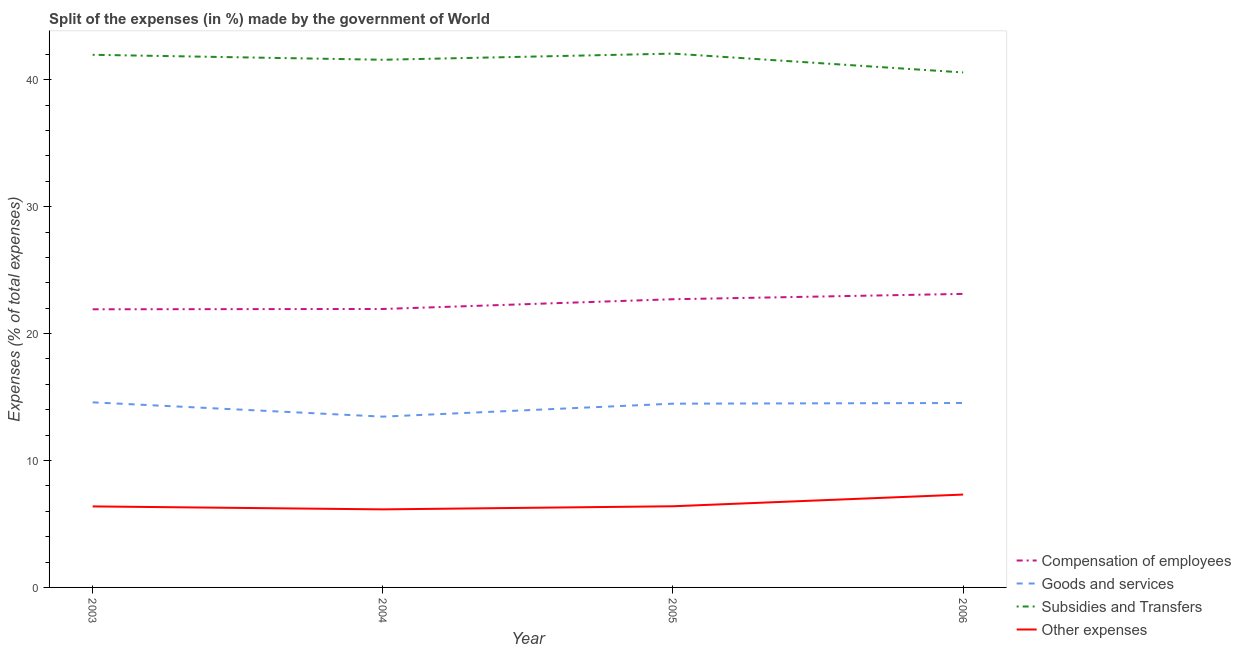Does the line corresponding to percentage of amount spent on subsidies intersect with the line corresponding to percentage of amount spent on compensation of employees?
Offer a very short reply. No. Is the number of lines equal to the number of legend labels?
Ensure brevity in your answer.  Yes. What is the percentage of amount spent on subsidies in 2004?
Provide a succinct answer. 41.58. Across all years, what is the maximum percentage of amount spent on goods and services?
Offer a very short reply. 14.58. Across all years, what is the minimum percentage of amount spent on other expenses?
Provide a succinct answer. 6.15. In which year was the percentage of amount spent on subsidies maximum?
Ensure brevity in your answer.  2005. In which year was the percentage of amount spent on subsidies minimum?
Offer a terse response. 2006. What is the total percentage of amount spent on compensation of employees in the graph?
Your answer should be compact. 89.69. What is the difference between the percentage of amount spent on compensation of employees in 2003 and that in 2005?
Make the answer very short. -0.79. What is the difference between the percentage of amount spent on goods and services in 2006 and the percentage of amount spent on subsidies in 2003?
Your answer should be compact. -27.44. What is the average percentage of amount spent on goods and services per year?
Your response must be concise. 14.26. In the year 2004, what is the difference between the percentage of amount spent on subsidies and percentage of amount spent on compensation of employees?
Provide a short and direct response. 19.64. In how many years, is the percentage of amount spent on compensation of employees greater than 32 %?
Your response must be concise. 0. What is the ratio of the percentage of amount spent on subsidies in 2005 to that in 2006?
Ensure brevity in your answer.  1.04. Is the difference between the percentage of amount spent on subsidies in 2004 and 2006 greater than the difference between the percentage of amount spent on goods and services in 2004 and 2006?
Provide a succinct answer. Yes. What is the difference between the highest and the second highest percentage of amount spent on goods and services?
Keep it short and to the point. 0.05. What is the difference between the highest and the lowest percentage of amount spent on compensation of employees?
Your answer should be very brief. 1.21. In how many years, is the percentage of amount spent on other expenses greater than the average percentage of amount spent on other expenses taken over all years?
Give a very brief answer. 1. Is the sum of the percentage of amount spent on other expenses in 2004 and 2006 greater than the maximum percentage of amount spent on goods and services across all years?
Give a very brief answer. No. Is it the case that in every year, the sum of the percentage of amount spent on goods and services and percentage of amount spent on subsidies is greater than the sum of percentage of amount spent on other expenses and percentage of amount spent on compensation of employees?
Make the answer very short. Yes. Is it the case that in every year, the sum of the percentage of amount spent on compensation of employees and percentage of amount spent on goods and services is greater than the percentage of amount spent on subsidies?
Ensure brevity in your answer.  No. Does the percentage of amount spent on compensation of employees monotonically increase over the years?
Provide a succinct answer. Yes. Is the percentage of amount spent on subsidies strictly less than the percentage of amount spent on compensation of employees over the years?
Offer a terse response. No. How many lines are there?
Your answer should be very brief. 4. What is the difference between two consecutive major ticks on the Y-axis?
Your answer should be very brief. 10. Does the graph contain grids?
Make the answer very short. No. What is the title of the graph?
Give a very brief answer. Split of the expenses (in %) made by the government of World. What is the label or title of the X-axis?
Your answer should be very brief. Year. What is the label or title of the Y-axis?
Keep it short and to the point. Expenses (% of total expenses). What is the Expenses (% of total expenses) in Compensation of employees in 2003?
Ensure brevity in your answer.  21.92. What is the Expenses (% of total expenses) in Goods and services in 2003?
Your response must be concise. 14.58. What is the Expenses (% of total expenses) in Subsidies and Transfers in 2003?
Give a very brief answer. 41.97. What is the Expenses (% of total expenses) of Other expenses in 2003?
Your response must be concise. 6.38. What is the Expenses (% of total expenses) in Compensation of employees in 2004?
Keep it short and to the point. 21.94. What is the Expenses (% of total expenses) in Goods and services in 2004?
Make the answer very short. 13.46. What is the Expenses (% of total expenses) of Subsidies and Transfers in 2004?
Ensure brevity in your answer.  41.58. What is the Expenses (% of total expenses) in Other expenses in 2004?
Make the answer very short. 6.15. What is the Expenses (% of total expenses) in Compensation of employees in 2005?
Ensure brevity in your answer.  22.71. What is the Expenses (% of total expenses) in Goods and services in 2005?
Your answer should be very brief. 14.48. What is the Expenses (% of total expenses) in Subsidies and Transfers in 2005?
Your answer should be compact. 42.06. What is the Expenses (% of total expenses) of Other expenses in 2005?
Your answer should be very brief. 6.39. What is the Expenses (% of total expenses) of Compensation of employees in 2006?
Offer a very short reply. 23.13. What is the Expenses (% of total expenses) in Goods and services in 2006?
Provide a short and direct response. 14.53. What is the Expenses (% of total expenses) of Subsidies and Transfers in 2006?
Offer a terse response. 40.58. What is the Expenses (% of total expenses) of Other expenses in 2006?
Your response must be concise. 7.32. Across all years, what is the maximum Expenses (% of total expenses) in Compensation of employees?
Offer a very short reply. 23.13. Across all years, what is the maximum Expenses (% of total expenses) in Goods and services?
Offer a terse response. 14.58. Across all years, what is the maximum Expenses (% of total expenses) in Subsidies and Transfers?
Make the answer very short. 42.06. Across all years, what is the maximum Expenses (% of total expenses) in Other expenses?
Offer a very short reply. 7.32. Across all years, what is the minimum Expenses (% of total expenses) in Compensation of employees?
Make the answer very short. 21.92. Across all years, what is the minimum Expenses (% of total expenses) in Goods and services?
Ensure brevity in your answer.  13.46. Across all years, what is the minimum Expenses (% of total expenses) of Subsidies and Transfers?
Provide a short and direct response. 40.58. Across all years, what is the minimum Expenses (% of total expenses) of Other expenses?
Offer a very short reply. 6.15. What is the total Expenses (% of total expenses) of Compensation of employees in the graph?
Provide a succinct answer. 89.69. What is the total Expenses (% of total expenses) in Goods and services in the graph?
Your response must be concise. 57.05. What is the total Expenses (% of total expenses) in Subsidies and Transfers in the graph?
Offer a terse response. 166.18. What is the total Expenses (% of total expenses) in Other expenses in the graph?
Make the answer very short. 26.25. What is the difference between the Expenses (% of total expenses) in Compensation of employees in 2003 and that in 2004?
Keep it short and to the point. -0.02. What is the difference between the Expenses (% of total expenses) in Goods and services in 2003 and that in 2004?
Ensure brevity in your answer.  1.13. What is the difference between the Expenses (% of total expenses) in Subsidies and Transfers in 2003 and that in 2004?
Make the answer very short. 0.39. What is the difference between the Expenses (% of total expenses) in Other expenses in 2003 and that in 2004?
Keep it short and to the point. 0.23. What is the difference between the Expenses (% of total expenses) in Compensation of employees in 2003 and that in 2005?
Offer a very short reply. -0.79. What is the difference between the Expenses (% of total expenses) of Goods and services in 2003 and that in 2005?
Your response must be concise. 0.1. What is the difference between the Expenses (% of total expenses) in Subsidies and Transfers in 2003 and that in 2005?
Ensure brevity in your answer.  -0.09. What is the difference between the Expenses (% of total expenses) in Other expenses in 2003 and that in 2005?
Provide a succinct answer. -0.01. What is the difference between the Expenses (% of total expenses) of Compensation of employees in 2003 and that in 2006?
Give a very brief answer. -1.21. What is the difference between the Expenses (% of total expenses) of Goods and services in 2003 and that in 2006?
Provide a succinct answer. 0.05. What is the difference between the Expenses (% of total expenses) of Subsidies and Transfers in 2003 and that in 2006?
Provide a short and direct response. 1.39. What is the difference between the Expenses (% of total expenses) of Other expenses in 2003 and that in 2006?
Your response must be concise. -0.93. What is the difference between the Expenses (% of total expenses) in Compensation of employees in 2004 and that in 2005?
Give a very brief answer. -0.77. What is the difference between the Expenses (% of total expenses) in Goods and services in 2004 and that in 2005?
Give a very brief answer. -1.02. What is the difference between the Expenses (% of total expenses) in Subsidies and Transfers in 2004 and that in 2005?
Your answer should be very brief. -0.48. What is the difference between the Expenses (% of total expenses) of Other expenses in 2004 and that in 2005?
Your answer should be very brief. -0.24. What is the difference between the Expenses (% of total expenses) in Compensation of employees in 2004 and that in 2006?
Provide a short and direct response. -1.19. What is the difference between the Expenses (% of total expenses) of Goods and services in 2004 and that in 2006?
Provide a succinct answer. -1.07. What is the difference between the Expenses (% of total expenses) of Subsidies and Transfers in 2004 and that in 2006?
Ensure brevity in your answer.  1. What is the difference between the Expenses (% of total expenses) in Other expenses in 2004 and that in 2006?
Keep it short and to the point. -1.17. What is the difference between the Expenses (% of total expenses) in Compensation of employees in 2005 and that in 2006?
Provide a succinct answer. -0.42. What is the difference between the Expenses (% of total expenses) in Goods and services in 2005 and that in 2006?
Keep it short and to the point. -0.05. What is the difference between the Expenses (% of total expenses) in Subsidies and Transfers in 2005 and that in 2006?
Provide a short and direct response. 1.48. What is the difference between the Expenses (% of total expenses) in Other expenses in 2005 and that in 2006?
Make the answer very short. -0.92. What is the difference between the Expenses (% of total expenses) in Compensation of employees in 2003 and the Expenses (% of total expenses) in Goods and services in 2004?
Your answer should be compact. 8.46. What is the difference between the Expenses (% of total expenses) of Compensation of employees in 2003 and the Expenses (% of total expenses) of Subsidies and Transfers in 2004?
Offer a terse response. -19.66. What is the difference between the Expenses (% of total expenses) in Compensation of employees in 2003 and the Expenses (% of total expenses) in Other expenses in 2004?
Offer a very short reply. 15.77. What is the difference between the Expenses (% of total expenses) in Goods and services in 2003 and the Expenses (% of total expenses) in Subsidies and Transfers in 2004?
Ensure brevity in your answer.  -26.99. What is the difference between the Expenses (% of total expenses) in Goods and services in 2003 and the Expenses (% of total expenses) in Other expenses in 2004?
Your answer should be very brief. 8.43. What is the difference between the Expenses (% of total expenses) in Subsidies and Transfers in 2003 and the Expenses (% of total expenses) in Other expenses in 2004?
Your response must be concise. 35.82. What is the difference between the Expenses (% of total expenses) of Compensation of employees in 2003 and the Expenses (% of total expenses) of Goods and services in 2005?
Offer a very short reply. 7.44. What is the difference between the Expenses (% of total expenses) of Compensation of employees in 2003 and the Expenses (% of total expenses) of Subsidies and Transfers in 2005?
Keep it short and to the point. -20.15. What is the difference between the Expenses (% of total expenses) in Compensation of employees in 2003 and the Expenses (% of total expenses) in Other expenses in 2005?
Give a very brief answer. 15.52. What is the difference between the Expenses (% of total expenses) of Goods and services in 2003 and the Expenses (% of total expenses) of Subsidies and Transfers in 2005?
Ensure brevity in your answer.  -27.48. What is the difference between the Expenses (% of total expenses) in Goods and services in 2003 and the Expenses (% of total expenses) in Other expenses in 2005?
Provide a short and direct response. 8.19. What is the difference between the Expenses (% of total expenses) of Subsidies and Transfers in 2003 and the Expenses (% of total expenses) of Other expenses in 2005?
Ensure brevity in your answer.  35.57. What is the difference between the Expenses (% of total expenses) in Compensation of employees in 2003 and the Expenses (% of total expenses) in Goods and services in 2006?
Provide a succinct answer. 7.38. What is the difference between the Expenses (% of total expenses) of Compensation of employees in 2003 and the Expenses (% of total expenses) of Subsidies and Transfers in 2006?
Provide a succinct answer. -18.66. What is the difference between the Expenses (% of total expenses) in Compensation of employees in 2003 and the Expenses (% of total expenses) in Other expenses in 2006?
Your answer should be very brief. 14.6. What is the difference between the Expenses (% of total expenses) of Goods and services in 2003 and the Expenses (% of total expenses) of Subsidies and Transfers in 2006?
Your response must be concise. -25.99. What is the difference between the Expenses (% of total expenses) in Goods and services in 2003 and the Expenses (% of total expenses) in Other expenses in 2006?
Provide a short and direct response. 7.27. What is the difference between the Expenses (% of total expenses) of Subsidies and Transfers in 2003 and the Expenses (% of total expenses) of Other expenses in 2006?
Provide a short and direct response. 34.65. What is the difference between the Expenses (% of total expenses) of Compensation of employees in 2004 and the Expenses (% of total expenses) of Goods and services in 2005?
Ensure brevity in your answer.  7.46. What is the difference between the Expenses (% of total expenses) in Compensation of employees in 2004 and the Expenses (% of total expenses) in Subsidies and Transfers in 2005?
Your answer should be very brief. -20.12. What is the difference between the Expenses (% of total expenses) in Compensation of employees in 2004 and the Expenses (% of total expenses) in Other expenses in 2005?
Provide a short and direct response. 15.55. What is the difference between the Expenses (% of total expenses) in Goods and services in 2004 and the Expenses (% of total expenses) in Subsidies and Transfers in 2005?
Provide a succinct answer. -28.6. What is the difference between the Expenses (% of total expenses) of Goods and services in 2004 and the Expenses (% of total expenses) of Other expenses in 2005?
Offer a very short reply. 7.06. What is the difference between the Expenses (% of total expenses) in Subsidies and Transfers in 2004 and the Expenses (% of total expenses) in Other expenses in 2005?
Your answer should be very brief. 35.18. What is the difference between the Expenses (% of total expenses) in Compensation of employees in 2004 and the Expenses (% of total expenses) in Goods and services in 2006?
Provide a succinct answer. 7.41. What is the difference between the Expenses (% of total expenses) in Compensation of employees in 2004 and the Expenses (% of total expenses) in Subsidies and Transfers in 2006?
Offer a terse response. -18.64. What is the difference between the Expenses (% of total expenses) in Compensation of employees in 2004 and the Expenses (% of total expenses) in Other expenses in 2006?
Provide a succinct answer. 14.62. What is the difference between the Expenses (% of total expenses) of Goods and services in 2004 and the Expenses (% of total expenses) of Subsidies and Transfers in 2006?
Offer a terse response. -27.12. What is the difference between the Expenses (% of total expenses) in Goods and services in 2004 and the Expenses (% of total expenses) in Other expenses in 2006?
Offer a very short reply. 6.14. What is the difference between the Expenses (% of total expenses) of Subsidies and Transfers in 2004 and the Expenses (% of total expenses) of Other expenses in 2006?
Provide a succinct answer. 34.26. What is the difference between the Expenses (% of total expenses) of Compensation of employees in 2005 and the Expenses (% of total expenses) of Goods and services in 2006?
Provide a short and direct response. 8.18. What is the difference between the Expenses (% of total expenses) in Compensation of employees in 2005 and the Expenses (% of total expenses) in Subsidies and Transfers in 2006?
Keep it short and to the point. -17.87. What is the difference between the Expenses (% of total expenses) in Compensation of employees in 2005 and the Expenses (% of total expenses) in Other expenses in 2006?
Your response must be concise. 15.39. What is the difference between the Expenses (% of total expenses) of Goods and services in 2005 and the Expenses (% of total expenses) of Subsidies and Transfers in 2006?
Offer a terse response. -26.1. What is the difference between the Expenses (% of total expenses) in Goods and services in 2005 and the Expenses (% of total expenses) in Other expenses in 2006?
Your answer should be very brief. 7.16. What is the difference between the Expenses (% of total expenses) in Subsidies and Transfers in 2005 and the Expenses (% of total expenses) in Other expenses in 2006?
Offer a very short reply. 34.74. What is the average Expenses (% of total expenses) of Compensation of employees per year?
Provide a succinct answer. 22.42. What is the average Expenses (% of total expenses) of Goods and services per year?
Offer a terse response. 14.26. What is the average Expenses (% of total expenses) in Subsidies and Transfers per year?
Offer a very short reply. 41.55. What is the average Expenses (% of total expenses) in Other expenses per year?
Ensure brevity in your answer.  6.56. In the year 2003, what is the difference between the Expenses (% of total expenses) in Compensation of employees and Expenses (% of total expenses) in Goods and services?
Your answer should be compact. 7.33. In the year 2003, what is the difference between the Expenses (% of total expenses) of Compensation of employees and Expenses (% of total expenses) of Subsidies and Transfers?
Keep it short and to the point. -20.05. In the year 2003, what is the difference between the Expenses (% of total expenses) in Compensation of employees and Expenses (% of total expenses) in Other expenses?
Make the answer very short. 15.53. In the year 2003, what is the difference between the Expenses (% of total expenses) in Goods and services and Expenses (% of total expenses) in Subsidies and Transfers?
Your response must be concise. -27.39. In the year 2003, what is the difference between the Expenses (% of total expenses) in Goods and services and Expenses (% of total expenses) in Other expenses?
Your answer should be compact. 8.2. In the year 2003, what is the difference between the Expenses (% of total expenses) of Subsidies and Transfers and Expenses (% of total expenses) of Other expenses?
Offer a very short reply. 35.58. In the year 2004, what is the difference between the Expenses (% of total expenses) in Compensation of employees and Expenses (% of total expenses) in Goods and services?
Provide a short and direct response. 8.48. In the year 2004, what is the difference between the Expenses (% of total expenses) in Compensation of employees and Expenses (% of total expenses) in Subsidies and Transfers?
Your response must be concise. -19.64. In the year 2004, what is the difference between the Expenses (% of total expenses) of Compensation of employees and Expenses (% of total expenses) of Other expenses?
Offer a terse response. 15.79. In the year 2004, what is the difference between the Expenses (% of total expenses) of Goods and services and Expenses (% of total expenses) of Subsidies and Transfers?
Make the answer very short. -28.12. In the year 2004, what is the difference between the Expenses (% of total expenses) of Goods and services and Expenses (% of total expenses) of Other expenses?
Your response must be concise. 7.31. In the year 2004, what is the difference between the Expenses (% of total expenses) of Subsidies and Transfers and Expenses (% of total expenses) of Other expenses?
Your answer should be compact. 35.43. In the year 2005, what is the difference between the Expenses (% of total expenses) of Compensation of employees and Expenses (% of total expenses) of Goods and services?
Keep it short and to the point. 8.23. In the year 2005, what is the difference between the Expenses (% of total expenses) in Compensation of employees and Expenses (% of total expenses) in Subsidies and Transfers?
Keep it short and to the point. -19.35. In the year 2005, what is the difference between the Expenses (% of total expenses) in Compensation of employees and Expenses (% of total expenses) in Other expenses?
Keep it short and to the point. 16.31. In the year 2005, what is the difference between the Expenses (% of total expenses) in Goods and services and Expenses (% of total expenses) in Subsidies and Transfers?
Your response must be concise. -27.58. In the year 2005, what is the difference between the Expenses (% of total expenses) in Goods and services and Expenses (% of total expenses) in Other expenses?
Your answer should be very brief. 8.08. In the year 2005, what is the difference between the Expenses (% of total expenses) of Subsidies and Transfers and Expenses (% of total expenses) of Other expenses?
Your answer should be very brief. 35.67. In the year 2006, what is the difference between the Expenses (% of total expenses) of Compensation of employees and Expenses (% of total expenses) of Goods and services?
Ensure brevity in your answer.  8.6. In the year 2006, what is the difference between the Expenses (% of total expenses) of Compensation of employees and Expenses (% of total expenses) of Subsidies and Transfers?
Your answer should be very brief. -17.45. In the year 2006, what is the difference between the Expenses (% of total expenses) of Compensation of employees and Expenses (% of total expenses) of Other expenses?
Offer a very short reply. 15.81. In the year 2006, what is the difference between the Expenses (% of total expenses) of Goods and services and Expenses (% of total expenses) of Subsidies and Transfers?
Offer a very short reply. -26.05. In the year 2006, what is the difference between the Expenses (% of total expenses) in Goods and services and Expenses (% of total expenses) in Other expenses?
Keep it short and to the point. 7.21. In the year 2006, what is the difference between the Expenses (% of total expenses) in Subsidies and Transfers and Expenses (% of total expenses) in Other expenses?
Give a very brief answer. 33.26. What is the ratio of the Expenses (% of total expenses) in Goods and services in 2003 to that in 2004?
Your answer should be very brief. 1.08. What is the ratio of the Expenses (% of total expenses) in Subsidies and Transfers in 2003 to that in 2004?
Ensure brevity in your answer.  1.01. What is the ratio of the Expenses (% of total expenses) in Other expenses in 2003 to that in 2004?
Your answer should be very brief. 1.04. What is the ratio of the Expenses (% of total expenses) in Compensation of employees in 2003 to that in 2005?
Provide a succinct answer. 0.97. What is the ratio of the Expenses (% of total expenses) in Subsidies and Transfers in 2003 to that in 2005?
Provide a succinct answer. 1. What is the ratio of the Expenses (% of total expenses) of Other expenses in 2003 to that in 2005?
Your answer should be very brief. 1. What is the ratio of the Expenses (% of total expenses) in Compensation of employees in 2003 to that in 2006?
Your answer should be compact. 0.95. What is the ratio of the Expenses (% of total expenses) of Goods and services in 2003 to that in 2006?
Your answer should be compact. 1. What is the ratio of the Expenses (% of total expenses) of Subsidies and Transfers in 2003 to that in 2006?
Give a very brief answer. 1.03. What is the ratio of the Expenses (% of total expenses) in Other expenses in 2003 to that in 2006?
Offer a terse response. 0.87. What is the ratio of the Expenses (% of total expenses) of Compensation of employees in 2004 to that in 2005?
Provide a short and direct response. 0.97. What is the ratio of the Expenses (% of total expenses) of Goods and services in 2004 to that in 2005?
Keep it short and to the point. 0.93. What is the ratio of the Expenses (% of total expenses) in Other expenses in 2004 to that in 2005?
Make the answer very short. 0.96. What is the ratio of the Expenses (% of total expenses) in Compensation of employees in 2004 to that in 2006?
Offer a very short reply. 0.95. What is the ratio of the Expenses (% of total expenses) in Goods and services in 2004 to that in 2006?
Your answer should be compact. 0.93. What is the ratio of the Expenses (% of total expenses) in Subsidies and Transfers in 2004 to that in 2006?
Provide a short and direct response. 1.02. What is the ratio of the Expenses (% of total expenses) of Other expenses in 2004 to that in 2006?
Your response must be concise. 0.84. What is the ratio of the Expenses (% of total expenses) of Compensation of employees in 2005 to that in 2006?
Offer a very short reply. 0.98. What is the ratio of the Expenses (% of total expenses) in Subsidies and Transfers in 2005 to that in 2006?
Ensure brevity in your answer.  1.04. What is the ratio of the Expenses (% of total expenses) in Other expenses in 2005 to that in 2006?
Your answer should be very brief. 0.87. What is the difference between the highest and the second highest Expenses (% of total expenses) of Compensation of employees?
Offer a very short reply. 0.42. What is the difference between the highest and the second highest Expenses (% of total expenses) of Goods and services?
Make the answer very short. 0.05. What is the difference between the highest and the second highest Expenses (% of total expenses) in Subsidies and Transfers?
Provide a succinct answer. 0.09. What is the difference between the highest and the second highest Expenses (% of total expenses) in Other expenses?
Provide a succinct answer. 0.92. What is the difference between the highest and the lowest Expenses (% of total expenses) in Compensation of employees?
Your answer should be very brief. 1.21. What is the difference between the highest and the lowest Expenses (% of total expenses) in Goods and services?
Your answer should be very brief. 1.13. What is the difference between the highest and the lowest Expenses (% of total expenses) in Subsidies and Transfers?
Keep it short and to the point. 1.48. What is the difference between the highest and the lowest Expenses (% of total expenses) of Other expenses?
Offer a very short reply. 1.17. 